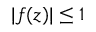Convert formula to latex. <formula><loc_0><loc_0><loc_500><loc_500>| f ( z ) | \leq 1</formula> 